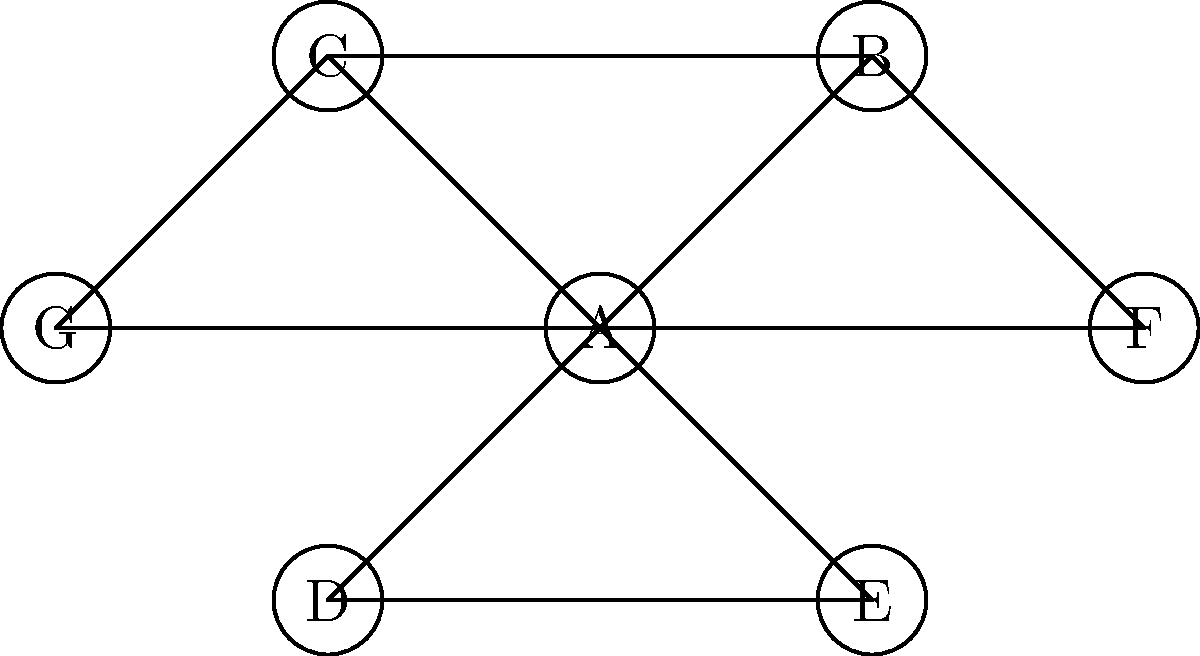In the social network graph of a business ecosystem shown above, which node represents the most influential actor based on degree centrality, and what strategic implications does this have for identifying key influencers? To answer this question, we need to follow these steps:

1. Understand degree centrality:
   Degree centrality is a measure of the number of direct connections a node has in a network. In a business ecosystem, it can represent the number of direct relationships or interactions an actor has with others.

2. Count the connections for each node:
   A: 6 connections
   B: 3 connections
   C: 3 connections
   D: 2 connections
   E: 2 connections
   F: 2 connections
   G: 2 connections

3. Identify the node with the highest degree centrality:
   Node A has the highest degree centrality with 6 connections.

4. Interpret the results in the context of a business ecosystem:
   The actor represented by Node A is likely to be the most influential in this network because they have the most direct connections. This could indicate:
   - Greater access to information and resources
   - More opportunities to influence others
   - A central position in the flow of ideas and innovations

5. Consider strategic implications:
   - Node A could be a key target for collaboration or partnership
   - Information or products could spread quickly through the network if introduced through Node A
   - Node A might act as a gatekeeper or broker between different parts of the network

6. Limitations of this analysis:
   - Degree centrality doesn't account for the quality or strength of connections
   - It doesn't consider the overall structure of the network beyond immediate connections
   - Other centrality measures (e.g., betweenness, closeness) might provide additional insights

By identifying Node A as a key influencer based on degree centrality, business strategists can focus their efforts on engaging with this actor to maximize their impact on the ecosystem.
Answer: Node A; highest degree centrality indicates greatest potential for influence and information flow in the business ecosystem. 